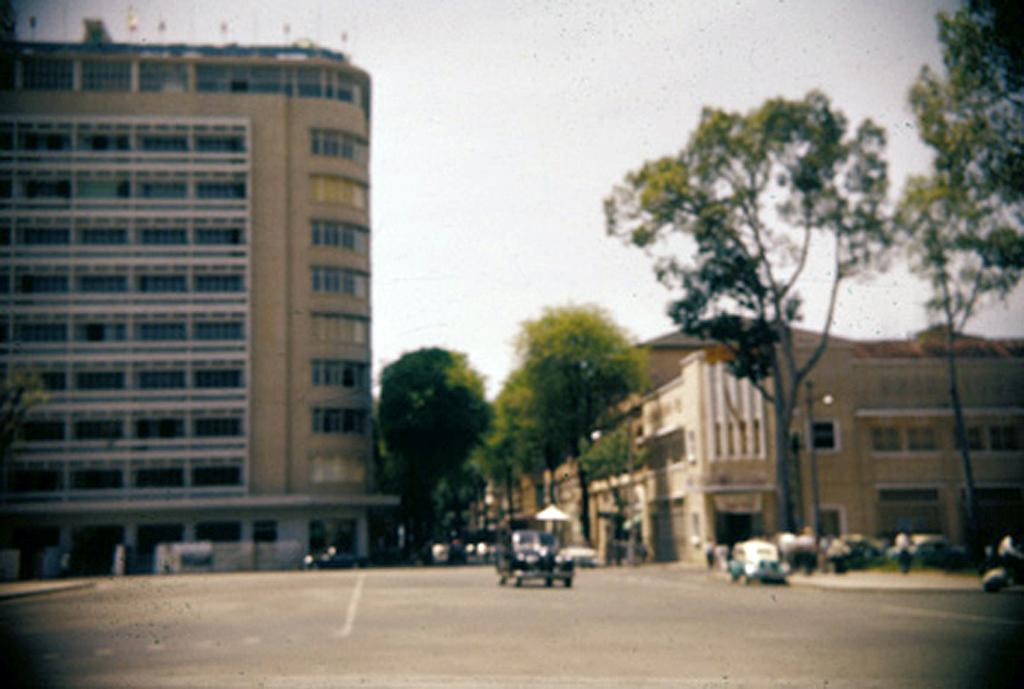What can be seen in the image that moves or transports people or goods? There are vehicles in the image that move or transport people or goods. What else can be seen in the image besides vehicles? There is a group of people and buildings in the background of the image. What other natural or man-made elements can be seen in the background of the image? There are trees and poles in the background of the image. Can you tell me how many fish are swimming in the sea in the image? There is no sea or fish present in the image. What type of rod is being used by the person in the image? There is no person or rod present in the image. 